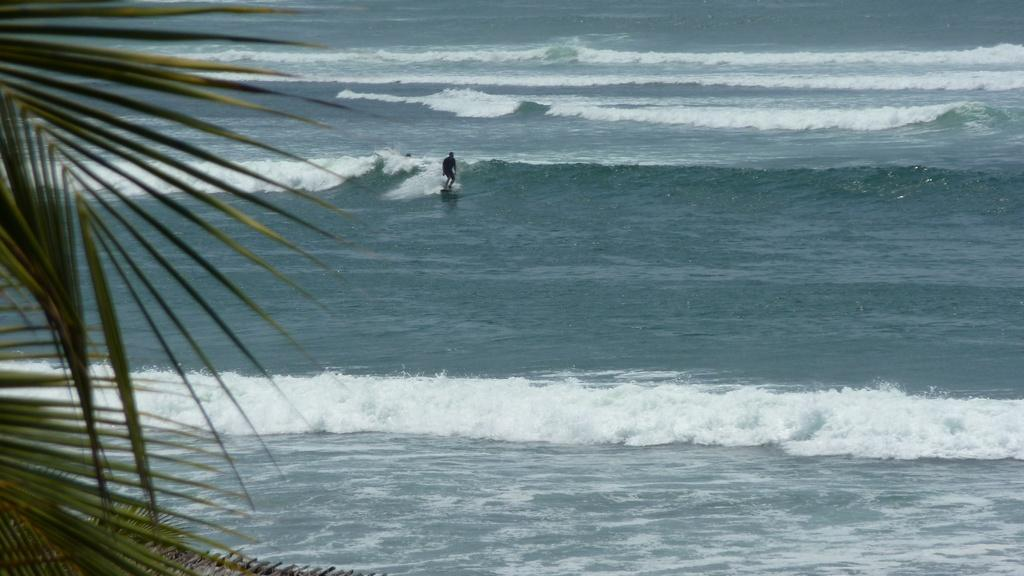What is the main feature of the image? The main feature of the image is water. What can be observed about the water in the image? There are waves in the water. What activity is the man in the image engaged in? The man is surfing in the water. What is located towards the left side of the image? There is a tree towards the left side of the image. What object can be seen towards the bottom of the image? There is an object towards the bottom of the image. What stage of development is the ship in the image? There is no ship present in the image. How does the man's throat look while he is surfing in the image? The image does not show the man's throat, so it cannot be determined from the image. 